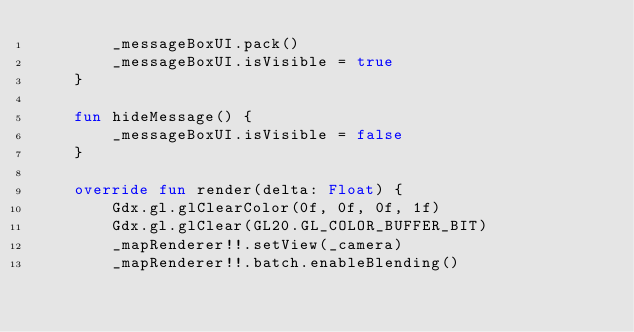Convert code to text. <code><loc_0><loc_0><loc_500><loc_500><_Kotlin_>        _messageBoxUI.pack()
        _messageBoxUI.isVisible = true
    }

    fun hideMessage() {
        _messageBoxUI.isVisible = false
    }

    override fun render(delta: Float) {
        Gdx.gl.glClearColor(0f, 0f, 0f, 1f)
        Gdx.gl.glClear(GL20.GL_COLOR_BUFFER_BIT)
        _mapRenderer!!.setView(_camera)
        _mapRenderer!!.batch.enableBlending()</code> 